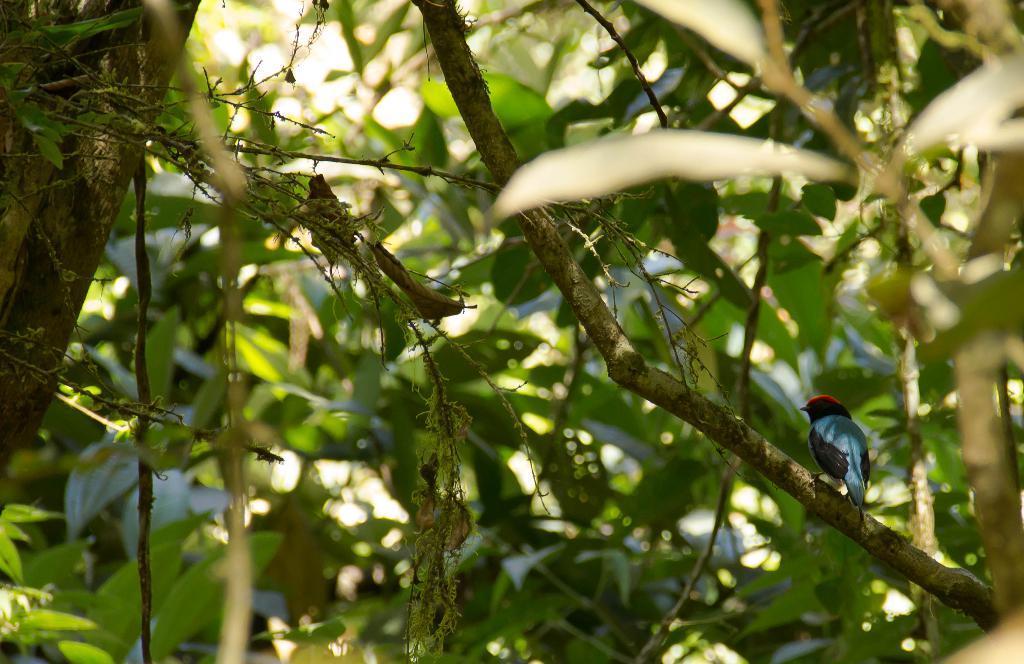How would you summarize this image in a sentence or two? In this image there are trees, there is a bird on the branch of the image. 